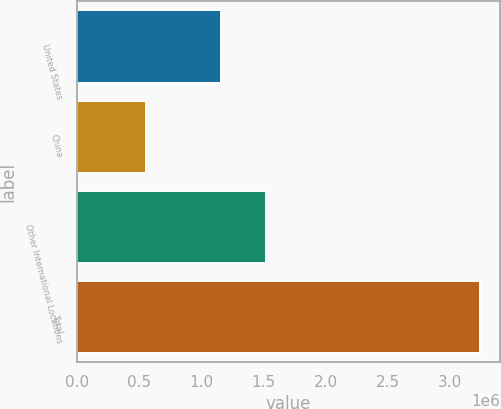<chart> <loc_0><loc_0><loc_500><loc_500><bar_chart><fcel>United States<fcel>China<fcel>Other International Locations<fcel>Total<nl><fcel>1.15935e+06<fcel>557243<fcel>1.51988e+06<fcel>3.23647e+06<nl></chart> 